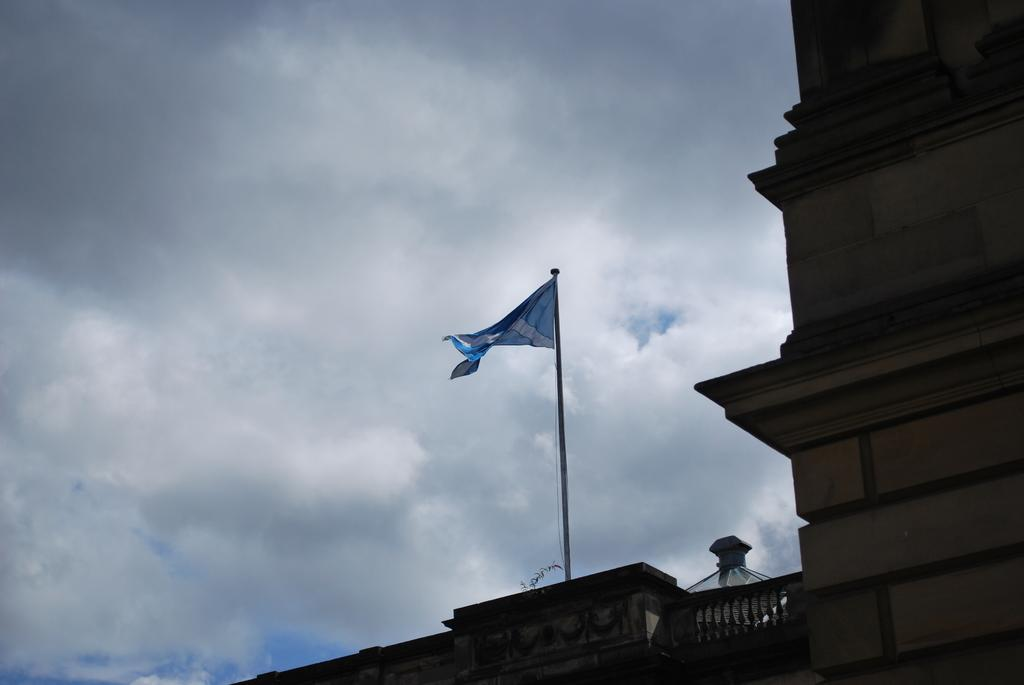What type of wall is featured on the building in the image? The building has a brick wall. What feature can be seen on the building that might be used for safety or decoration? The building has a railing. What is attached to the building and represents a country or organization? There is a flag on the building, attached to a pole. What can be seen in the background of the image? The sky is visible in the background. What type of coal is being used to fuel the building in the image? There is no coal present in the image, and the building is not being fueled by coal. 